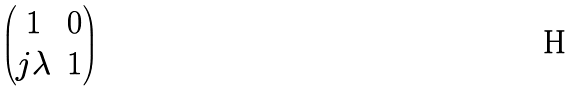<formula> <loc_0><loc_0><loc_500><loc_500>\begin{pmatrix} 1 & 0 \\ j \lambda & 1 \end{pmatrix}</formula> 